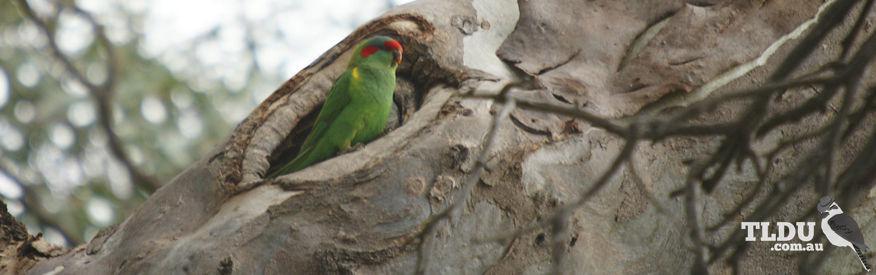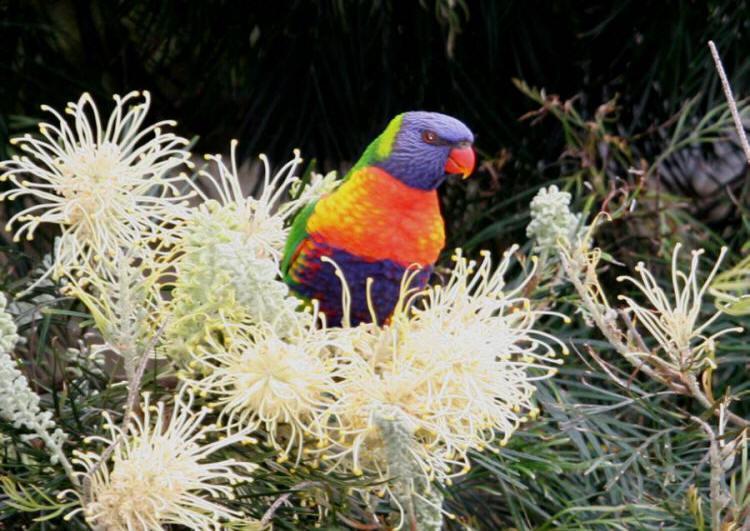The first image is the image on the left, the second image is the image on the right. Assess this claim about the two images: "there are 4 parrots in the image pair". Correct or not? Answer yes or no. No. The first image is the image on the left, the second image is the image on the right. Analyze the images presented: Is the assertion "There are four parrots." valid? Answer yes or no. No. 